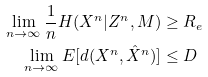<formula> <loc_0><loc_0><loc_500><loc_500>\lim _ { n \rightarrow \infty } \frac { 1 } { n } H ( X ^ { n } | Z ^ { n } , M ) & \geq R _ { e } \\ \lim _ { n \rightarrow \infty } E [ d ( X ^ { n } , \hat { X } ^ { n } ) ] & \leq D</formula> 